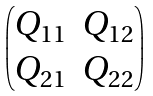Convert formula to latex. <formula><loc_0><loc_0><loc_500><loc_500>\begin{pmatrix} Q _ { 1 1 } & Q _ { 1 2 } \\ Q _ { 2 1 } & Q _ { 2 2 } \end{pmatrix}</formula> 